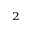<formula> <loc_0><loc_0><loc_500><loc_500>_ { 2 }</formula> 